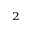<formula> <loc_0><loc_0><loc_500><loc_500>_ { 2 }</formula> 